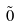Convert formula to latex. <formula><loc_0><loc_0><loc_500><loc_500>\tilde { 0 }</formula> 